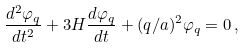Convert formula to latex. <formula><loc_0><loc_0><loc_500><loc_500>\frac { d ^ { 2 } \varphi _ { q } } { d t ^ { 2 } } + 3 H \frac { d \varphi _ { q } } { d t } + ( q / a ) ^ { 2 } \varphi _ { q } = 0 \, ,</formula> 